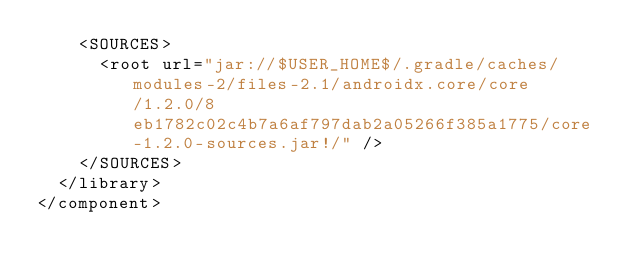Convert code to text. <code><loc_0><loc_0><loc_500><loc_500><_XML_>    <SOURCES>
      <root url="jar://$USER_HOME$/.gradle/caches/modules-2/files-2.1/androidx.core/core/1.2.0/8eb1782c02c4b7a6af797dab2a05266f385a1775/core-1.2.0-sources.jar!/" />
    </SOURCES>
  </library>
</component></code> 